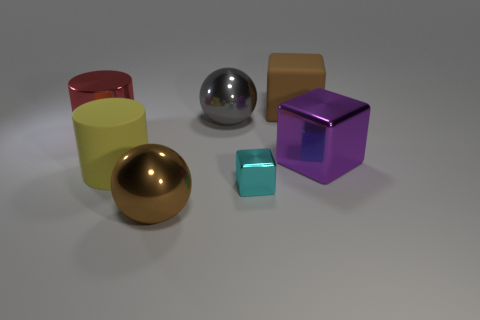What size is the other thing that is the same shape as the red metal thing?
Provide a succinct answer. Large. What number of objects are rubber things behind the gray metal ball or objects left of the tiny block?
Offer a terse response. 5. There is a brown thing that is to the right of the large metal ball behind the small cyan metallic object; what shape is it?
Offer a very short reply. Cube. Are there any other things of the same color as the small shiny thing?
Provide a succinct answer. No. Are there any other things that are the same size as the red shiny object?
Offer a terse response. Yes. What number of things are either red rubber blocks or brown things?
Your answer should be very brief. 2. Are there any red cylinders that have the same size as the yellow object?
Offer a terse response. Yes. The purple metal thing has what shape?
Make the answer very short. Cube. Are there more gray metallic balls that are left of the red object than big metallic spheres that are in front of the gray ball?
Keep it short and to the point. No. There is a large block that is on the right side of the brown rubber thing; is its color the same as the metallic thing in front of the tiny object?
Ensure brevity in your answer.  No. 